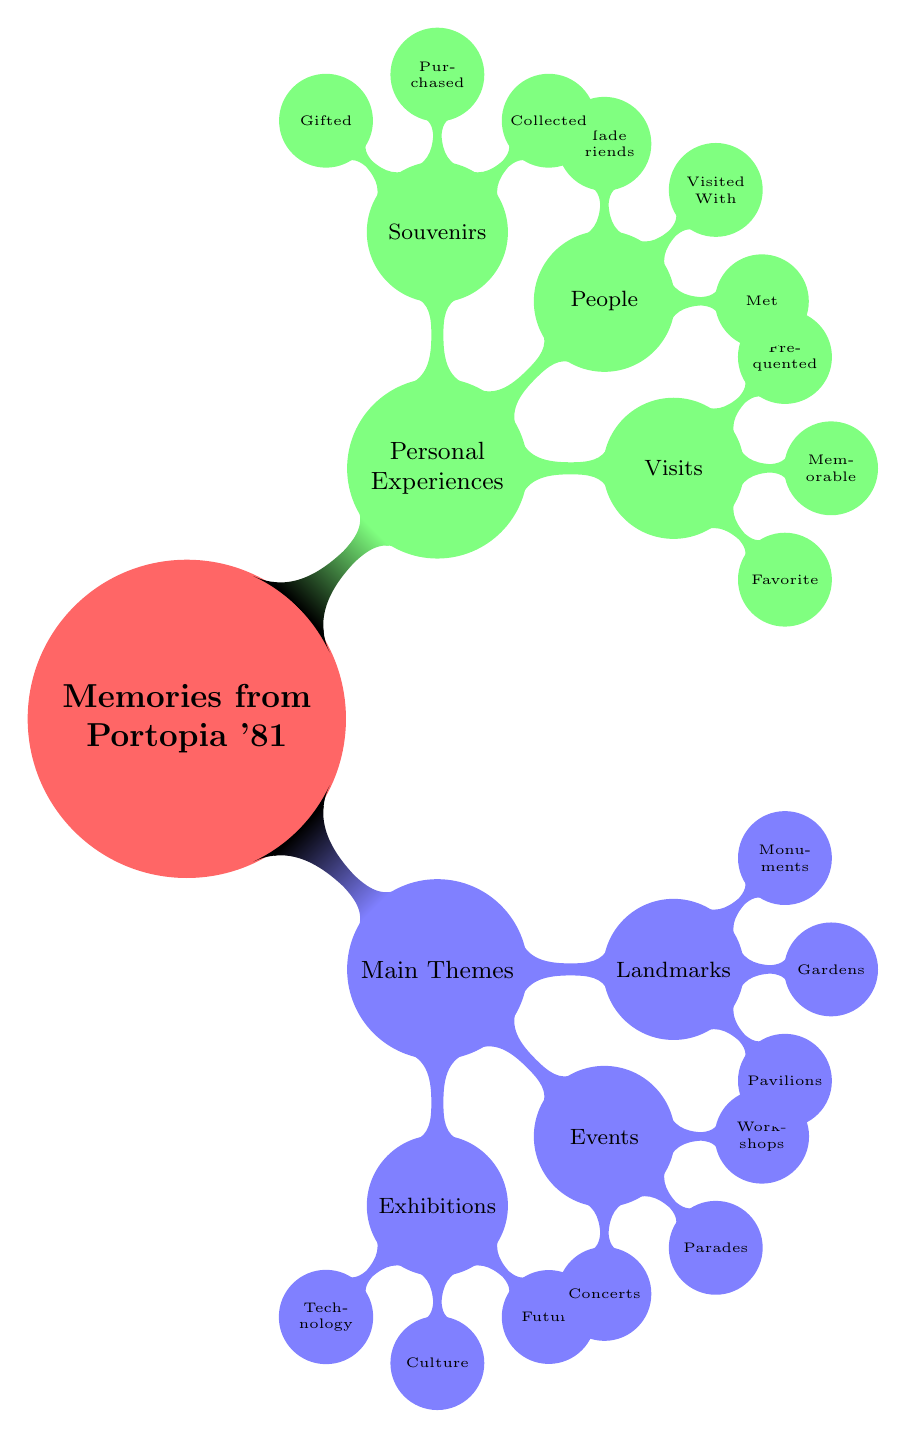What are the main categories in the Mind Map? The Mind Map contains two main categories: "Main Themes" and "Personal Experiences." These categories represent the overall structure of the memories from Portopia '81.
Answer: Main Themes, Personal Experiences How many events are listed under Main Themes? Under "Events," there are three listed: Concerts, Parades, and Workshops. Thus, the total count for events is three.
Answer: 3 What was the most memorable visit mentioned? The Mind Map states that the most memorable visit was to the "Futuristic City Model," emphasizing its significance in the overall experience.
Answer: Futuristic City Model Who did the participants visit the expo with? According to the "People" subcategory, participants visited with "Family," indicating a common experience shared during the expo.
Answer: Family What type of technician exhibition is mentioned? The technology exhibition listed is "Expo Digital Ware," which reflects advancements and innovations showcased during Portopia '81.
Answer: Expo Digital Ware Are there any landmarks associated with gardens? Yes, the "Gardens" node refers to "Port Island Seaside Park," indicating a specific landmark associated with gardens in the event.
Answer: Port Island Seaside Park What souvenirs were collected? The Mind Map specifies that "Expo Badges" were collected as souvenirs, making it a notable item among the memorabilia.
Answer: Expo Badges What kind of concert was featured at the event? The concert mentioned was performed by the "Kobe Philharmonic Orchestra," highlighting a cultural aspect of the events at Portopia '81.
Answer: Kobe Philharmonic Orchestra How many categories are under Personal Experiences? The "Personal Experiences" section includes three categories: Visits, People, and Souvenirs, leading to a total of three categories.
Answer: 3 